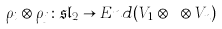Convert formula to latex. <formula><loc_0><loc_0><loc_500><loc_500>\rho _ { i } \otimes \rho _ { j } \colon \mathfrak { s l } _ { 2 } \to E n d ( V _ { 1 } \otimes \dots \otimes V _ { n } )</formula> 